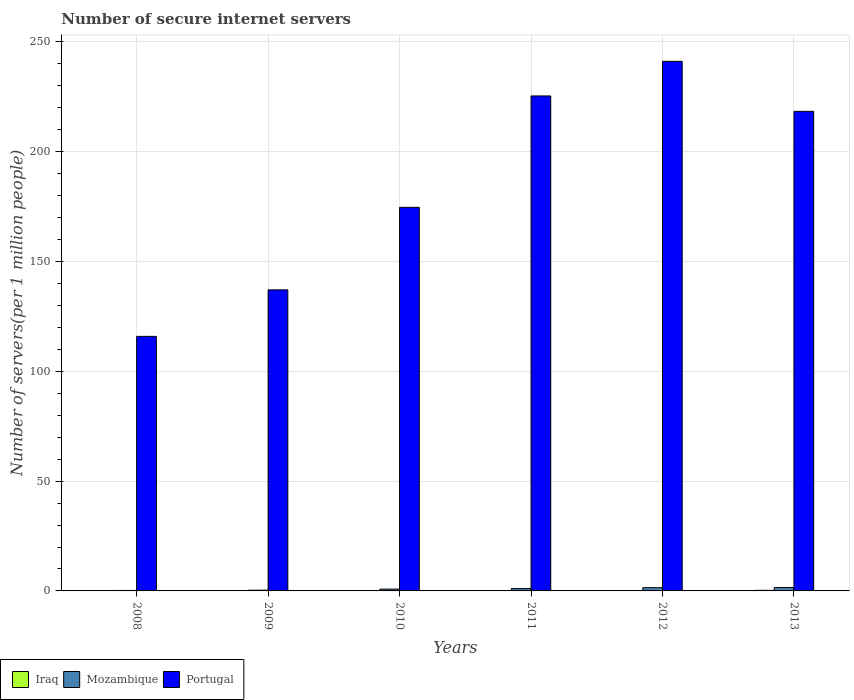Are the number of bars on each tick of the X-axis equal?
Your answer should be very brief. Yes. What is the label of the 5th group of bars from the left?
Your answer should be compact. 2012. In how many cases, is the number of bars for a given year not equal to the number of legend labels?
Offer a very short reply. 0. What is the number of secure internet servers in Mozambique in 2013?
Your answer should be very brief. 1.55. Across all years, what is the maximum number of secure internet servers in Mozambique?
Ensure brevity in your answer.  1.55. Across all years, what is the minimum number of secure internet servers in Portugal?
Make the answer very short. 115.93. In which year was the number of secure internet servers in Iraq minimum?
Your response must be concise. 2012. What is the total number of secure internet servers in Mozambique in the graph?
Offer a terse response. 5.48. What is the difference between the number of secure internet servers in Iraq in 2008 and that in 2011?
Offer a very short reply. 0.01. What is the difference between the number of secure internet servers in Portugal in 2011 and the number of secure internet servers in Iraq in 2010?
Your response must be concise. 225.3. What is the average number of secure internet servers in Portugal per year?
Make the answer very short. 185.46. In the year 2012, what is the difference between the number of secure internet servers in Portugal and number of secure internet servers in Iraq?
Give a very brief answer. 241.06. In how many years, is the number of secure internet servers in Iraq greater than 210?
Your answer should be very brief. 0. What is the ratio of the number of secure internet servers in Portugal in 2008 to that in 2011?
Your response must be concise. 0.51. Is the number of secure internet servers in Portugal in 2008 less than that in 2010?
Your response must be concise. Yes. Is the difference between the number of secure internet servers in Portugal in 2009 and 2011 greater than the difference between the number of secure internet servers in Iraq in 2009 and 2011?
Keep it short and to the point. No. What is the difference between the highest and the second highest number of secure internet servers in Iraq?
Your response must be concise. 0.13. What is the difference between the highest and the lowest number of secure internet servers in Mozambique?
Give a very brief answer. 1.33. Is the sum of the number of secure internet servers in Portugal in 2010 and 2012 greater than the maximum number of secure internet servers in Mozambique across all years?
Keep it short and to the point. Yes. What does the 2nd bar from the left in 2011 represents?
Provide a short and direct response. Mozambique. What does the 3rd bar from the right in 2011 represents?
Give a very brief answer. Iraq. Is it the case that in every year, the sum of the number of secure internet servers in Portugal and number of secure internet servers in Iraq is greater than the number of secure internet servers in Mozambique?
Ensure brevity in your answer.  Yes. Are the values on the major ticks of Y-axis written in scientific E-notation?
Ensure brevity in your answer.  No. Does the graph contain any zero values?
Keep it short and to the point. No. Does the graph contain grids?
Your response must be concise. Yes. How many legend labels are there?
Provide a succinct answer. 3. What is the title of the graph?
Offer a very short reply. Number of secure internet servers. What is the label or title of the Y-axis?
Your answer should be compact. Number of servers(per 1 million people). What is the Number of servers(per 1 million people) in Iraq in 2008?
Your answer should be very brief. 0.14. What is the Number of servers(per 1 million people) in Mozambique in 2008?
Your answer should be very brief. 0.22. What is the Number of servers(per 1 million people) of Portugal in 2008?
Your response must be concise. 115.93. What is the Number of servers(per 1 million people) of Iraq in 2009?
Make the answer very short. 0.13. What is the Number of servers(per 1 million people) of Mozambique in 2009?
Your response must be concise. 0.34. What is the Number of servers(per 1 million people) of Portugal in 2009?
Ensure brevity in your answer.  137.11. What is the Number of servers(per 1 million people) of Iraq in 2010?
Your response must be concise. 0.13. What is the Number of servers(per 1 million people) in Mozambique in 2010?
Keep it short and to the point. 0.82. What is the Number of servers(per 1 million people) in Portugal in 2010?
Provide a short and direct response. 174.69. What is the Number of servers(per 1 million people) in Iraq in 2011?
Your answer should be very brief. 0.13. What is the Number of servers(per 1 million people) in Mozambique in 2011?
Offer a very short reply. 1.08. What is the Number of servers(per 1 million people) of Portugal in 2011?
Give a very brief answer. 225.43. What is the Number of servers(per 1 million people) in Iraq in 2012?
Make the answer very short. 0.12. What is the Number of servers(per 1 million people) in Mozambique in 2012?
Offer a very short reply. 1.48. What is the Number of servers(per 1 million people) in Portugal in 2012?
Offer a terse response. 241.18. What is the Number of servers(per 1 million people) of Iraq in 2013?
Keep it short and to the point. 0.27. What is the Number of servers(per 1 million people) of Mozambique in 2013?
Offer a very short reply. 1.55. What is the Number of servers(per 1 million people) of Portugal in 2013?
Provide a short and direct response. 218.41. Across all years, what is the maximum Number of servers(per 1 million people) in Iraq?
Your response must be concise. 0.27. Across all years, what is the maximum Number of servers(per 1 million people) in Mozambique?
Your answer should be compact. 1.55. Across all years, what is the maximum Number of servers(per 1 million people) of Portugal?
Offer a very short reply. 241.18. Across all years, what is the minimum Number of servers(per 1 million people) in Iraq?
Provide a short and direct response. 0.12. Across all years, what is the minimum Number of servers(per 1 million people) of Mozambique?
Offer a terse response. 0.22. Across all years, what is the minimum Number of servers(per 1 million people) of Portugal?
Give a very brief answer. 115.93. What is the total Number of servers(per 1 million people) in Iraq in the graph?
Your response must be concise. 0.91. What is the total Number of servers(per 1 million people) of Mozambique in the graph?
Your response must be concise. 5.48. What is the total Number of servers(per 1 million people) in Portugal in the graph?
Provide a succinct answer. 1112.75. What is the difference between the Number of servers(per 1 million people) of Iraq in 2008 and that in 2009?
Offer a terse response. 0. What is the difference between the Number of servers(per 1 million people) of Mozambique in 2008 and that in 2009?
Ensure brevity in your answer.  -0.12. What is the difference between the Number of servers(per 1 million people) in Portugal in 2008 and that in 2009?
Your response must be concise. -21.18. What is the difference between the Number of servers(per 1 million people) in Iraq in 2008 and that in 2010?
Your response must be concise. 0.01. What is the difference between the Number of servers(per 1 million people) of Mozambique in 2008 and that in 2010?
Make the answer very short. -0.6. What is the difference between the Number of servers(per 1 million people) of Portugal in 2008 and that in 2010?
Make the answer very short. -58.76. What is the difference between the Number of servers(per 1 million people) of Iraq in 2008 and that in 2011?
Provide a short and direct response. 0.01. What is the difference between the Number of servers(per 1 million people) of Mozambique in 2008 and that in 2011?
Ensure brevity in your answer.  -0.86. What is the difference between the Number of servers(per 1 million people) of Portugal in 2008 and that in 2011?
Provide a succinct answer. -109.5. What is the difference between the Number of servers(per 1 million people) of Iraq in 2008 and that in 2012?
Offer a terse response. 0.02. What is the difference between the Number of servers(per 1 million people) in Mozambique in 2008 and that in 2012?
Your response must be concise. -1.26. What is the difference between the Number of servers(per 1 million people) of Portugal in 2008 and that in 2012?
Give a very brief answer. -125.25. What is the difference between the Number of servers(per 1 million people) of Iraq in 2008 and that in 2013?
Ensure brevity in your answer.  -0.13. What is the difference between the Number of servers(per 1 million people) of Mozambique in 2008 and that in 2013?
Your answer should be very brief. -1.33. What is the difference between the Number of servers(per 1 million people) of Portugal in 2008 and that in 2013?
Make the answer very short. -102.48. What is the difference between the Number of servers(per 1 million people) in Iraq in 2009 and that in 2010?
Your response must be concise. 0. What is the difference between the Number of servers(per 1 million people) of Mozambique in 2009 and that in 2010?
Provide a succinct answer. -0.48. What is the difference between the Number of servers(per 1 million people) in Portugal in 2009 and that in 2010?
Provide a succinct answer. -37.58. What is the difference between the Number of servers(per 1 million people) in Iraq in 2009 and that in 2011?
Provide a succinct answer. 0.01. What is the difference between the Number of servers(per 1 million people) of Mozambique in 2009 and that in 2011?
Make the answer very short. -0.74. What is the difference between the Number of servers(per 1 million people) in Portugal in 2009 and that in 2011?
Offer a very short reply. -88.32. What is the difference between the Number of servers(per 1 million people) of Iraq in 2009 and that in 2012?
Offer a very short reply. 0.01. What is the difference between the Number of servers(per 1 million people) of Mozambique in 2009 and that in 2012?
Offer a very short reply. -1.14. What is the difference between the Number of servers(per 1 million people) of Portugal in 2009 and that in 2012?
Provide a succinct answer. -104.07. What is the difference between the Number of servers(per 1 million people) of Iraq in 2009 and that in 2013?
Provide a short and direct response. -0.13. What is the difference between the Number of servers(per 1 million people) of Mozambique in 2009 and that in 2013?
Make the answer very short. -1.21. What is the difference between the Number of servers(per 1 million people) of Portugal in 2009 and that in 2013?
Your answer should be very brief. -81.3. What is the difference between the Number of servers(per 1 million people) of Iraq in 2010 and that in 2011?
Offer a very short reply. 0. What is the difference between the Number of servers(per 1 million people) in Mozambique in 2010 and that in 2011?
Offer a terse response. -0.26. What is the difference between the Number of servers(per 1 million people) of Portugal in 2010 and that in 2011?
Offer a terse response. -50.74. What is the difference between the Number of servers(per 1 million people) of Iraq in 2010 and that in 2012?
Your answer should be compact. 0.01. What is the difference between the Number of servers(per 1 million people) of Mozambique in 2010 and that in 2012?
Your answer should be very brief. -0.65. What is the difference between the Number of servers(per 1 million people) of Portugal in 2010 and that in 2012?
Offer a terse response. -66.49. What is the difference between the Number of servers(per 1 million people) in Iraq in 2010 and that in 2013?
Ensure brevity in your answer.  -0.14. What is the difference between the Number of servers(per 1 million people) in Mozambique in 2010 and that in 2013?
Give a very brief answer. -0.73. What is the difference between the Number of servers(per 1 million people) of Portugal in 2010 and that in 2013?
Offer a very short reply. -43.72. What is the difference between the Number of servers(per 1 million people) in Iraq in 2011 and that in 2012?
Ensure brevity in your answer.  0. What is the difference between the Number of servers(per 1 million people) in Mozambique in 2011 and that in 2012?
Provide a short and direct response. -0.4. What is the difference between the Number of servers(per 1 million people) of Portugal in 2011 and that in 2012?
Offer a very short reply. -15.75. What is the difference between the Number of servers(per 1 million people) of Iraq in 2011 and that in 2013?
Keep it short and to the point. -0.14. What is the difference between the Number of servers(per 1 million people) of Mozambique in 2011 and that in 2013?
Provide a succinct answer. -0.47. What is the difference between the Number of servers(per 1 million people) in Portugal in 2011 and that in 2013?
Ensure brevity in your answer.  7.02. What is the difference between the Number of servers(per 1 million people) of Iraq in 2012 and that in 2013?
Your answer should be compact. -0.14. What is the difference between the Number of servers(per 1 million people) in Mozambique in 2012 and that in 2013?
Your response must be concise. -0.07. What is the difference between the Number of servers(per 1 million people) in Portugal in 2012 and that in 2013?
Your response must be concise. 22.77. What is the difference between the Number of servers(per 1 million people) in Iraq in 2008 and the Number of servers(per 1 million people) in Mozambique in 2009?
Provide a succinct answer. -0.2. What is the difference between the Number of servers(per 1 million people) in Iraq in 2008 and the Number of servers(per 1 million people) in Portugal in 2009?
Provide a succinct answer. -136.97. What is the difference between the Number of servers(per 1 million people) of Mozambique in 2008 and the Number of servers(per 1 million people) of Portugal in 2009?
Keep it short and to the point. -136.89. What is the difference between the Number of servers(per 1 million people) in Iraq in 2008 and the Number of servers(per 1 million people) in Mozambique in 2010?
Your response must be concise. -0.69. What is the difference between the Number of servers(per 1 million people) in Iraq in 2008 and the Number of servers(per 1 million people) in Portugal in 2010?
Keep it short and to the point. -174.55. What is the difference between the Number of servers(per 1 million people) in Mozambique in 2008 and the Number of servers(per 1 million people) in Portugal in 2010?
Ensure brevity in your answer.  -174.47. What is the difference between the Number of servers(per 1 million people) in Iraq in 2008 and the Number of servers(per 1 million people) in Mozambique in 2011?
Offer a very short reply. -0.94. What is the difference between the Number of servers(per 1 million people) of Iraq in 2008 and the Number of servers(per 1 million people) of Portugal in 2011?
Your response must be concise. -225.29. What is the difference between the Number of servers(per 1 million people) in Mozambique in 2008 and the Number of servers(per 1 million people) in Portugal in 2011?
Provide a succinct answer. -225.21. What is the difference between the Number of servers(per 1 million people) in Iraq in 2008 and the Number of servers(per 1 million people) in Mozambique in 2012?
Your response must be concise. -1.34. What is the difference between the Number of servers(per 1 million people) in Iraq in 2008 and the Number of servers(per 1 million people) in Portugal in 2012?
Give a very brief answer. -241.05. What is the difference between the Number of servers(per 1 million people) in Mozambique in 2008 and the Number of servers(per 1 million people) in Portugal in 2012?
Offer a terse response. -240.97. What is the difference between the Number of servers(per 1 million people) in Iraq in 2008 and the Number of servers(per 1 million people) in Mozambique in 2013?
Offer a terse response. -1.41. What is the difference between the Number of servers(per 1 million people) of Iraq in 2008 and the Number of servers(per 1 million people) of Portugal in 2013?
Give a very brief answer. -218.28. What is the difference between the Number of servers(per 1 million people) of Mozambique in 2008 and the Number of servers(per 1 million people) of Portugal in 2013?
Give a very brief answer. -218.19. What is the difference between the Number of servers(per 1 million people) in Iraq in 2009 and the Number of servers(per 1 million people) in Mozambique in 2010?
Give a very brief answer. -0.69. What is the difference between the Number of servers(per 1 million people) in Iraq in 2009 and the Number of servers(per 1 million people) in Portugal in 2010?
Offer a terse response. -174.56. What is the difference between the Number of servers(per 1 million people) of Mozambique in 2009 and the Number of servers(per 1 million people) of Portugal in 2010?
Your response must be concise. -174.35. What is the difference between the Number of servers(per 1 million people) in Iraq in 2009 and the Number of servers(per 1 million people) in Mozambique in 2011?
Provide a succinct answer. -0.95. What is the difference between the Number of servers(per 1 million people) of Iraq in 2009 and the Number of servers(per 1 million people) of Portugal in 2011?
Your response must be concise. -225.3. What is the difference between the Number of servers(per 1 million people) in Mozambique in 2009 and the Number of servers(per 1 million people) in Portugal in 2011?
Offer a very short reply. -225.09. What is the difference between the Number of servers(per 1 million people) of Iraq in 2009 and the Number of servers(per 1 million people) of Mozambique in 2012?
Make the answer very short. -1.34. What is the difference between the Number of servers(per 1 million people) in Iraq in 2009 and the Number of servers(per 1 million people) in Portugal in 2012?
Make the answer very short. -241.05. What is the difference between the Number of servers(per 1 million people) of Mozambique in 2009 and the Number of servers(per 1 million people) of Portugal in 2012?
Your answer should be very brief. -240.84. What is the difference between the Number of servers(per 1 million people) of Iraq in 2009 and the Number of servers(per 1 million people) of Mozambique in 2013?
Make the answer very short. -1.42. What is the difference between the Number of servers(per 1 million people) of Iraq in 2009 and the Number of servers(per 1 million people) of Portugal in 2013?
Offer a very short reply. -218.28. What is the difference between the Number of servers(per 1 million people) in Mozambique in 2009 and the Number of servers(per 1 million people) in Portugal in 2013?
Give a very brief answer. -218.07. What is the difference between the Number of servers(per 1 million people) in Iraq in 2010 and the Number of servers(per 1 million people) in Mozambique in 2011?
Make the answer very short. -0.95. What is the difference between the Number of servers(per 1 million people) of Iraq in 2010 and the Number of servers(per 1 million people) of Portugal in 2011?
Offer a very short reply. -225.3. What is the difference between the Number of servers(per 1 million people) in Mozambique in 2010 and the Number of servers(per 1 million people) in Portugal in 2011?
Your answer should be very brief. -224.61. What is the difference between the Number of servers(per 1 million people) in Iraq in 2010 and the Number of servers(per 1 million people) in Mozambique in 2012?
Provide a succinct answer. -1.35. What is the difference between the Number of servers(per 1 million people) in Iraq in 2010 and the Number of servers(per 1 million people) in Portugal in 2012?
Ensure brevity in your answer.  -241.05. What is the difference between the Number of servers(per 1 million people) in Mozambique in 2010 and the Number of servers(per 1 million people) in Portugal in 2012?
Ensure brevity in your answer.  -240.36. What is the difference between the Number of servers(per 1 million people) in Iraq in 2010 and the Number of servers(per 1 million people) in Mozambique in 2013?
Make the answer very short. -1.42. What is the difference between the Number of servers(per 1 million people) in Iraq in 2010 and the Number of servers(per 1 million people) in Portugal in 2013?
Offer a very short reply. -218.28. What is the difference between the Number of servers(per 1 million people) in Mozambique in 2010 and the Number of servers(per 1 million people) in Portugal in 2013?
Provide a succinct answer. -217.59. What is the difference between the Number of servers(per 1 million people) of Iraq in 2011 and the Number of servers(per 1 million people) of Mozambique in 2012?
Offer a terse response. -1.35. What is the difference between the Number of servers(per 1 million people) of Iraq in 2011 and the Number of servers(per 1 million people) of Portugal in 2012?
Ensure brevity in your answer.  -241.06. What is the difference between the Number of servers(per 1 million people) of Mozambique in 2011 and the Number of servers(per 1 million people) of Portugal in 2012?
Give a very brief answer. -240.1. What is the difference between the Number of servers(per 1 million people) in Iraq in 2011 and the Number of servers(per 1 million people) in Mozambique in 2013?
Your answer should be very brief. -1.42. What is the difference between the Number of servers(per 1 million people) of Iraq in 2011 and the Number of servers(per 1 million people) of Portugal in 2013?
Your response must be concise. -218.29. What is the difference between the Number of servers(per 1 million people) in Mozambique in 2011 and the Number of servers(per 1 million people) in Portugal in 2013?
Make the answer very short. -217.33. What is the difference between the Number of servers(per 1 million people) in Iraq in 2012 and the Number of servers(per 1 million people) in Mozambique in 2013?
Provide a short and direct response. -1.43. What is the difference between the Number of servers(per 1 million people) of Iraq in 2012 and the Number of servers(per 1 million people) of Portugal in 2013?
Keep it short and to the point. -218.29. What is the difference between the Number of servers(per 1 million people) of Mozambique in 2012 and the Number of servers(per 1 million people) of Portugal in 2013?
Offer a terse response. -216.94. What is the average Number of servers(per 1 million people) of Iraq per year?
Keep it short and to the point. 0.15. What is the average Number of servers(per 1 million people) of Mozambique per year?
Make the answer very short. 0.91. What is the average Number of servers(per 1 million people) of Portugal per year?
Your answer should be compact. 185.46. In the year 2008, what is the difference between the Number of servers(per 1 million people) in Iraq and Number of servers(per 1 million people) in Mozambique?
Keep it short and to the point. -0.08. In the year 2008, what is the difference between the Number of servers(per 1 million people) in Iraq and Number of servers(per 1 million people) in Portugal?
Give a very brief answer. -115.79. In the year 2008, what is the difference between the Number of servers(per 1 million people) in Mozambique and Number of servers(per 1 million people) in Portugal?
Offer a very short reply. -115.71. In the year 2009, what is the difference between the Number of servers(per 1 million people) in Iraq and Number of servers(per 1 million people) in Mozambique?
Your response must be concise. -0.2. In the year 2009, what is the difference between the Number of servers(per 1 million people) in Iraq and Number of servers(per 1 million people) in Portugal?
Offer a terse response. -136.98. In the year 2009, what is the difference between the Number of servers(per 1 million people) in Mozambique and Number of servers(per 1 million people) in Portugal?
Your response must be concise. -136.77. In the year 2010, what is the difference between the Number of servers(per 1 million people) of Iraq and Number of servers(per 1 million people) of Mozambique?
Provide a succinct answer. -0.69. In the year 2010, what is the difference between the Number of servers(per 1 million people) in Iraq and Number of servers(per 1 million people) in Portugal?
Give a very brief answer. -174.56. In the year 2010, what is the difference between the Number of servers(per 1 million people) in Mozambique and Number of servers(per 1 million people) in Portugal?
Provide a short and direct response. -173.87. In the year 2011, what is the difference between the Number of servers(per 1 million people) in Iraq and Number of servers(per 1 million people) in Mozambique?
Make the answer very short. -0.95. In the year 2011, what is the difference between the Number of servers(per 1 million people) of Iraq and Number of servers(per 1 million people) of Portugal?
Ensure brevity in your answer.  -225.31. In the year 2011, what is the difference between the Number of servers(per 1 million people) of Mozambique and Number of servers(per 1 million people) of Portugal?
Make the answer very short. -224.35. In the year 2012, what is the difference between the Number of servers(per 1 million people) in Iraq and Number of servers(per 1 million people) in Mozambique?
Your answer should be compact. -1.35. In the year 2012, what is the difference between the Number of servers(per 1 million people) in Iraq and Number of servers(per 1 million people) in Portugal?
Offer a terse response. -241.06. In the year 2012, what is the difference between the Number of servers(per 1 million people) in Mozambique and Number of servers(per 1 million people) in Portugal?
Your answer should be very brief. -239.71. In the year 2013, what is the difference between the Number of servers(per 1 million people) in Iraq and Number of servers(per 1 million people) in Mozambique?
Ensure brevity in your answer.  -1.28. In the year 2013, what is the difference between the Number of servers(per 1 million people) of Iraq and Number of servers(per 1 million people) of Portugal?
Provide a short and direct response. -218.15. In the year 2013, what is the difference between the Number of servers(per 1 million people) in Mozambique and Number of servers(per 1 million people) in Portugal?
Your response must be concise. -216.86. What is the ratio of the Number of servers(per 1 million people) in Iraq in 2008 to that in 2009?
Your answer should be compact. 1.03. What is the ratio of the Number of servers(per 1 million people) in Mozambique in 2008 to that in 2009?
Offer a terse response. 0.64. What is the ratio of the Number of servers(per 1 million people) of Portugal in 2008 to that in 2009?
Offer a terse response. 0.85. What is the ratio of the Number of servers(per 1 million people) in Iraq in 2008 to that in 2010?
Give a very brief answer. 1.06. What is the ratio of the Number of servers(per 1 million people) of Mozambique in 2008 to that in 2010?
Your answer should be compact. 0.26. What is the ratio of the Number of servers(per 1 million people) of Portugal in 2008 to that in 2010?
Provide a succinct answer. 0.66. What is the ratio of the Number of servers(per 1 million people) in Iraq in 2008 to that in 2011?
Provide a succinct answer. 1.09. What is the ratio of the Number of servers(per 1 million people) in Mozambique in 2008 to that in 2011?
Offer a terse response. 0.2. What is the ratio of the Number of servers(per 1 million people) of Portugal in 2008 to that in 2011?
Your answer should be very brief. 0.51. What is the ratio of the Number of servers(per 1 million people) in Iraq in 2008 to that in 2012?
Provide a succinct answer. 1.12. What is the ratio of the Number of servers(per 1 million people) in Mozambique in 2008 to that in 2012?
Your answer should be very brief. 0.15. What is the ratio of the Number of servers(per 1 million people) of Portugal in 2008 to that in 2012?
Give a very brief answer. 0.48. What is the ratio of the Number of servers(per 1 million people) of Iraq in 2008 to that in 2013?
Make the answer very short. 0.51. What is the ratio of the Number of servers(per 1 million people) in Mozambique in 2008 to that in 2013?
Your response must be concise. 0.14. What is the ratio of the Number of servers(per 1 million people) in Portugal in 2008 to that in 2013?
Give a very brief answer. 0.53. What is the ratio of the Number of servers(per 1 million people) of Iraq in 2009 to that in 2010?
Your answer should be compact. 1.03. What is the ratio of the Number of servers(per 1 million people) of Mozambique in 2009 to that in 2010?
Provide a succinct answer. 0.41. What is the ratio of the Number of servers(per 1 million people) in Portugal in 2009 to that in 2010?
Your response must be concise. 0.78. What is the ratio of the Number of servers(per 1 million people) of Iraq in 2009 to that in 2011?
Give a very brief answer. 1.06. What is the ratio of the Number of servers(per 1 million people) of Mozambique in 2009 to that in 2011?
Give a very brief answer. 0.31. What is the ratio of the Number of servers(per 1 million people) in Portugal in 2009 to that in 2011?
Provide a short and direct response. 0.61. What is the ratio of the Number of servers(per 1 million people) in Iraq in 2009 to that in 2012?
Keep it short and to the point. 1.09. What is the ratio of the Number of servers(per 1 million people) of Mozambique in 2009 to that in 2012?
Offer a very short reply. 0.23. What is the ratio of the Number of servers(per 1 million people) in Portugal in 2009 to that in 2012?
Your answer should be compact. 0.57. What is the ratio of the Number of servers(per 1 million people) in Iraq in 2009 to that in 2013?
Ensure brevity in your answer.  0.5. What is the ratio of the Number of servers(per 1 million people) of Mozambique in 2009 to that in 2013?
Provide a succinct answer. 0.22. What is the ratio of the Number of servers(per 1 million people) of Portugal in 2009 to that in 2013?
Offer a terse response. 0.63. What is the ratio of the Number of servers(per 1 million people) in Iraq in 2010 to that in 2011?
Provide a succinct answer. 1.03. What is the ratio of the Number of servers(per 1 million people) in Mozambique in 2010 to that in 2011?
Give a very brief answer. 0.76. What is the ratio of the Number of servers(per 1 million people) in Portugal in 2010 to that in 2011?
Your answer should be very brief. 0.77. What is the ratio of the Number of servers(per 1 million people) of Iraq in 2010 to that in 2012?
Your answer should be very brief. 1.06. What is the ratio of the Number of servers(per 1 million people) of Mozambique in 2010 to that in 2012?
Offer a very short reply. 0.56. What is the ratio of the Number of servers(per 1 million people) of Portugal in 2010 to that in 2012?
Your answer should be very brief. 0.72. What is the ratio of the Number of servers(per 1 million people) in Iraq in 2010 to that in 2013?
Keep it short and to the point. 0.49. What is the ratio of the Number of servers(per 1 million people) in Mozambique in 2010 to that in 2013?
Your response must be concise. 0.53. What is the ratio of the Number of servers(per 1 million people) in Portugal in 2010 to that in 2013?
Provide a short and direct response. 0.8. What is the ratio of the Number of servers(per 1 million people) in Iraq in 2011 to that in 2012?
Offer a very short reply. 1.03. What is the ratio of the Number of servers(per 1 million people) of Mozambique in 2011 to that in 2012?
Give a very brief answer. 0.73. What is the ratio of the Number of servers(per 1 million people) in Portugal in 2011 to that in 2012?
Provide a succinct answer. 0.93. What is the ratio of the Number of servers(per 1 million people) of Iraq in 2011 to that in 2013?
Make the answer very short. 0.47. What is the ratio of the Number of servers(per 1 million people) in Mozambique in 2011 to that in 2013?
Give a very brief answer. 0.7. What is the ratio of the Number of servers(per 1 million people) of Portugal in 2011 to that in 2013?
Offer a terse response. 1.03. What is the ratio of the Number of servers(per 1 million people) of Iraq in 2012 to that in 2013?
Provide a short and direct response. 0.46. What is the ratio of the Number of servers(per 1 million people) in Mozambique in 2012 to that in 2013?
Offer a very short reply. 0.95. What is the ratio of the Number of servers(per 1 million people) of Portugal in 2012 to that in 2013?
Provide a succinct answer. 1.1. What is the difference between the highest and the second highest Number of servers(per 1 million people) of Iraq?
Your answer should be compact. 0.13. What is the difference between the highest and the second highest Number of servers(per 1 million people) of Mozambique?
Offer a very short reply. 0.07. What is the difference between the highest and the second highest Number of servers(per 1 million people) of Portugal?
Offer a terse response. 15.75. What is the difference between the highest and the lowest Number of servers(per 1 million people) of Iraq?
Make the answer very short. 0.14. What is the difference between the highest and the lowest Number of servers(per 1 million people) of Mozambique?
Make the answer very short. 1.33. What is the difference between the highest and the lowest Number of servers(per 1 million people) of Portugal?
Provide a succinct answer. 125.25. 